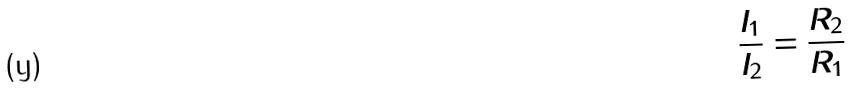Convert formula to latex. <formula><loc_0><loc_0><loc_500><loc_500>\frac { I _ { 1 } } { I _ { 2 } } = \frac { R _ { 2 } } { R _ { 1 } }</formula> 